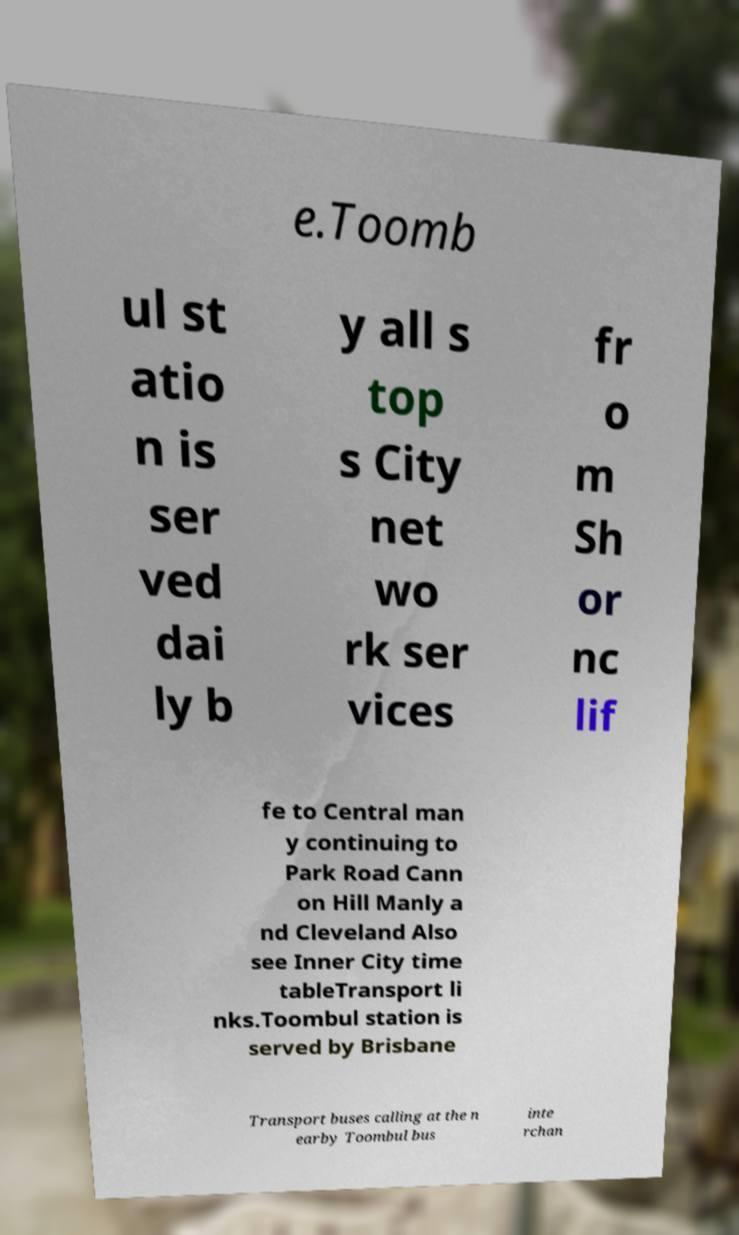For documentation purposes, I need the text within this image transcribed. Could you provide that? e.Toomb ul st atio n is ser ved dai ly b y all s top s City net wo rk ser vices fr o m Sh or nc lif fe to Central man y continuing to Park Road Cann on Hill Manly a nd Cleveland Also see Inner City time tableTransport li nks.Toombul station is served by Brisbane Transport buses calling at the n earby Toombul bus inte rchan 